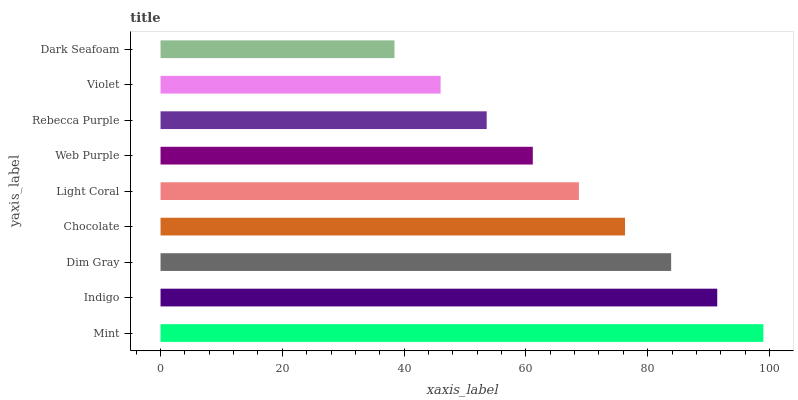Is Dark Seafoam the minimum?
Answer yes or no. Yes. Is Mint the maximum?
Answer yes or no. Yes. Is Indigo the minimum?
Answer yes or no. No. Is Indigo the maximum?
Answer yes or no. No. Is Mint greater than Indigo?
Answer yes or no. Yes. Is Indigo less than Mint?
Answer yes or no. Yes. Is Indigo greater than Mint?
Answer yes or no. No. Is Mint less than Indigo?
Answer yes or no. No. Is Light Coral the high median?
Answer yes or no. Yes. Is Light Coral the low median?
Answer yes or no. Yes. Is Indigo the high median?
Answer yes or no. No. Is Rebecca Purple the low median?
Answer yes or no. No. 